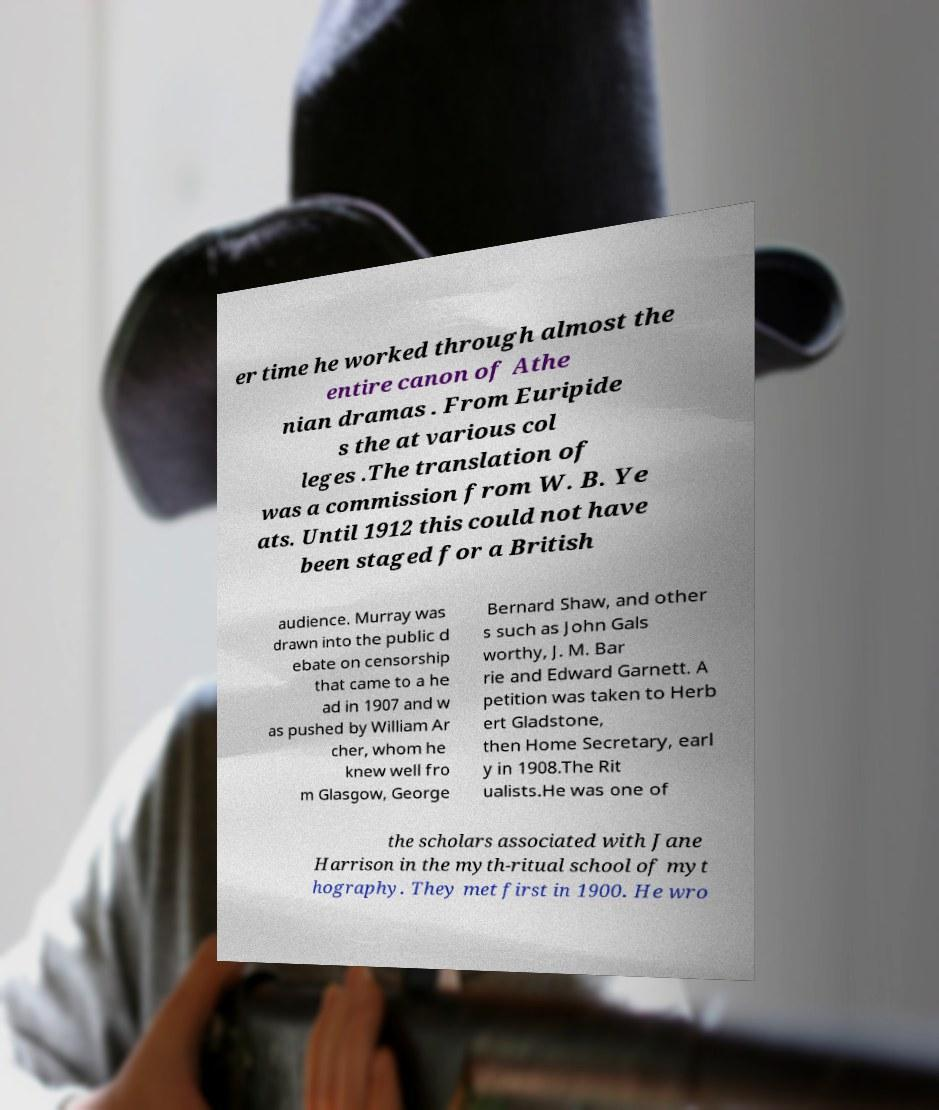There's text embedded in this image that I need extracted. Can you transcribe it verbatim? er time he worked through almost the entire canon of Athe nian dramas . From Euripide s the at various col leges .The translation of was a commission from W. B. Ye ats. Until 1912 this could not have been staged for a British audience. Murray was drawn into the public d ebate on censorship that came to a he ad in 1907 and w as pushed by William Ar cher, whom he knew well fro m Glasgow, George Bernard Shaw, and other s such as John Gals worthy, J. M. Bar rie and Edward Garnett. A petition was taken to Herb ert Gladstone, then Home Secretary, earl y in 1908.The Rit ualists.He was one of the scholars associated with Jane Harrison in the myth-ritual school of myt hography. They met first in 1900. He wro 